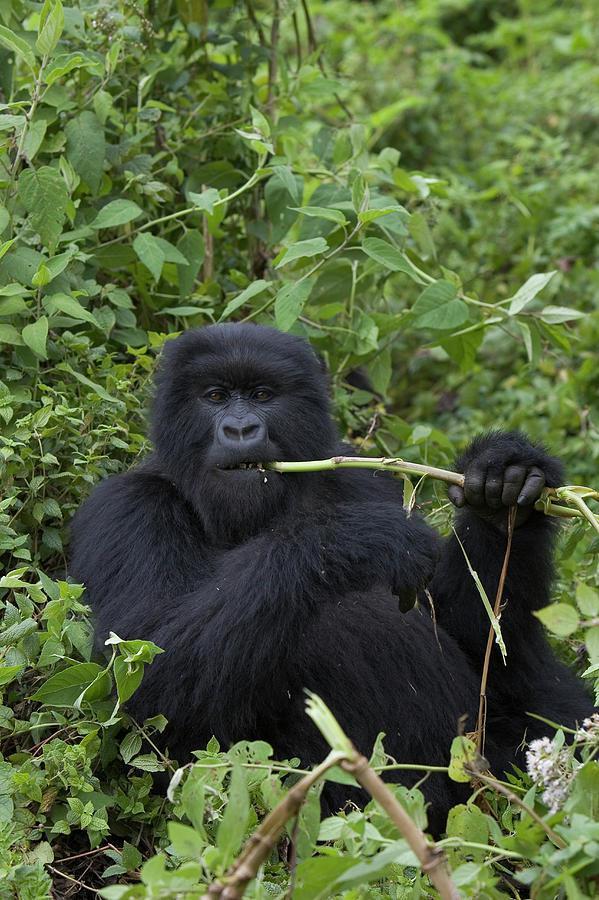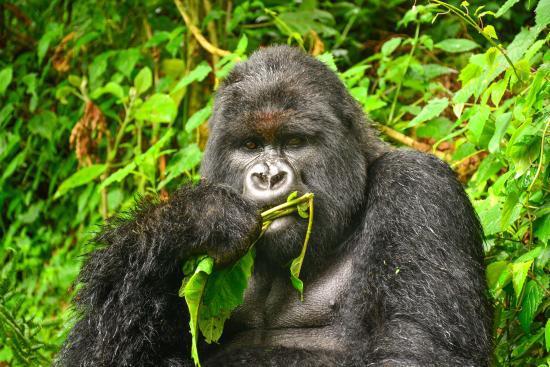The first image is the image on the left, the second image is the image on the right. Considering the images on both sides, is "In the right image, a gorilla is holding green foliage to its mouth with the arm on the left [of the image]." valid? Answer yes or no. Yes. 